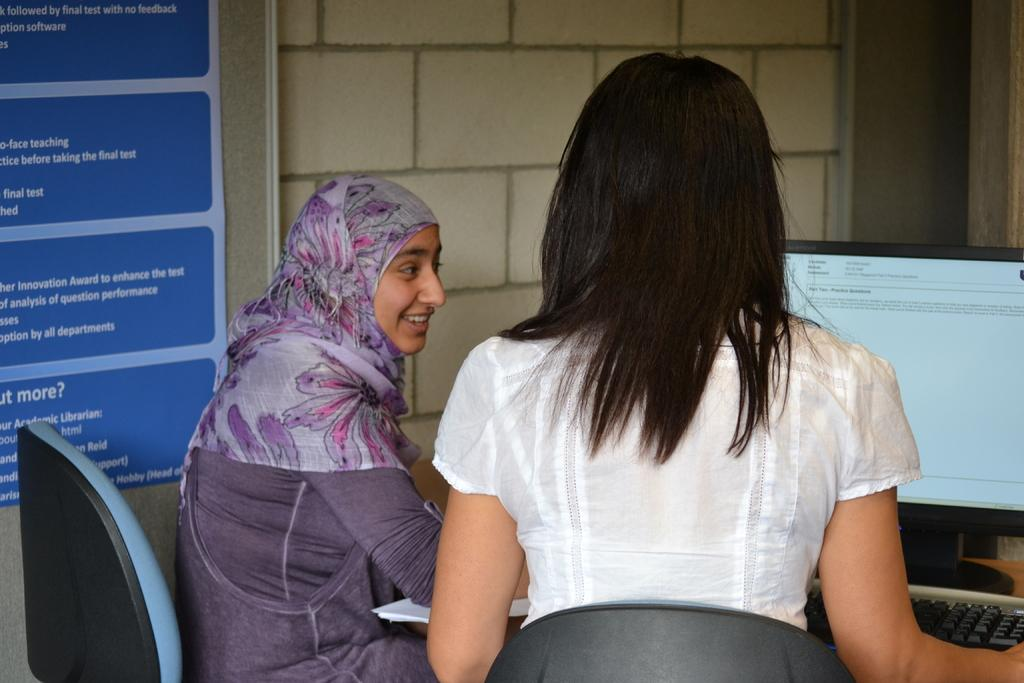How many women are in the image? There are two women in the image. What are the women doing in the image? The women are sitting on chairs. Where are the chairs located in relation to the table? The chairs are in front of a table. What is on the table in the image? There is a system and papers on the table. What is on the wall in the image? There is a board on the wall. How many giraffes are standing behind the women in the image? There are no giraffes present in the image. What type of low-level security system is on the table in the image? There is no mention of a security system in the image, and the system on the table is not specified as being low-level or related to security. 